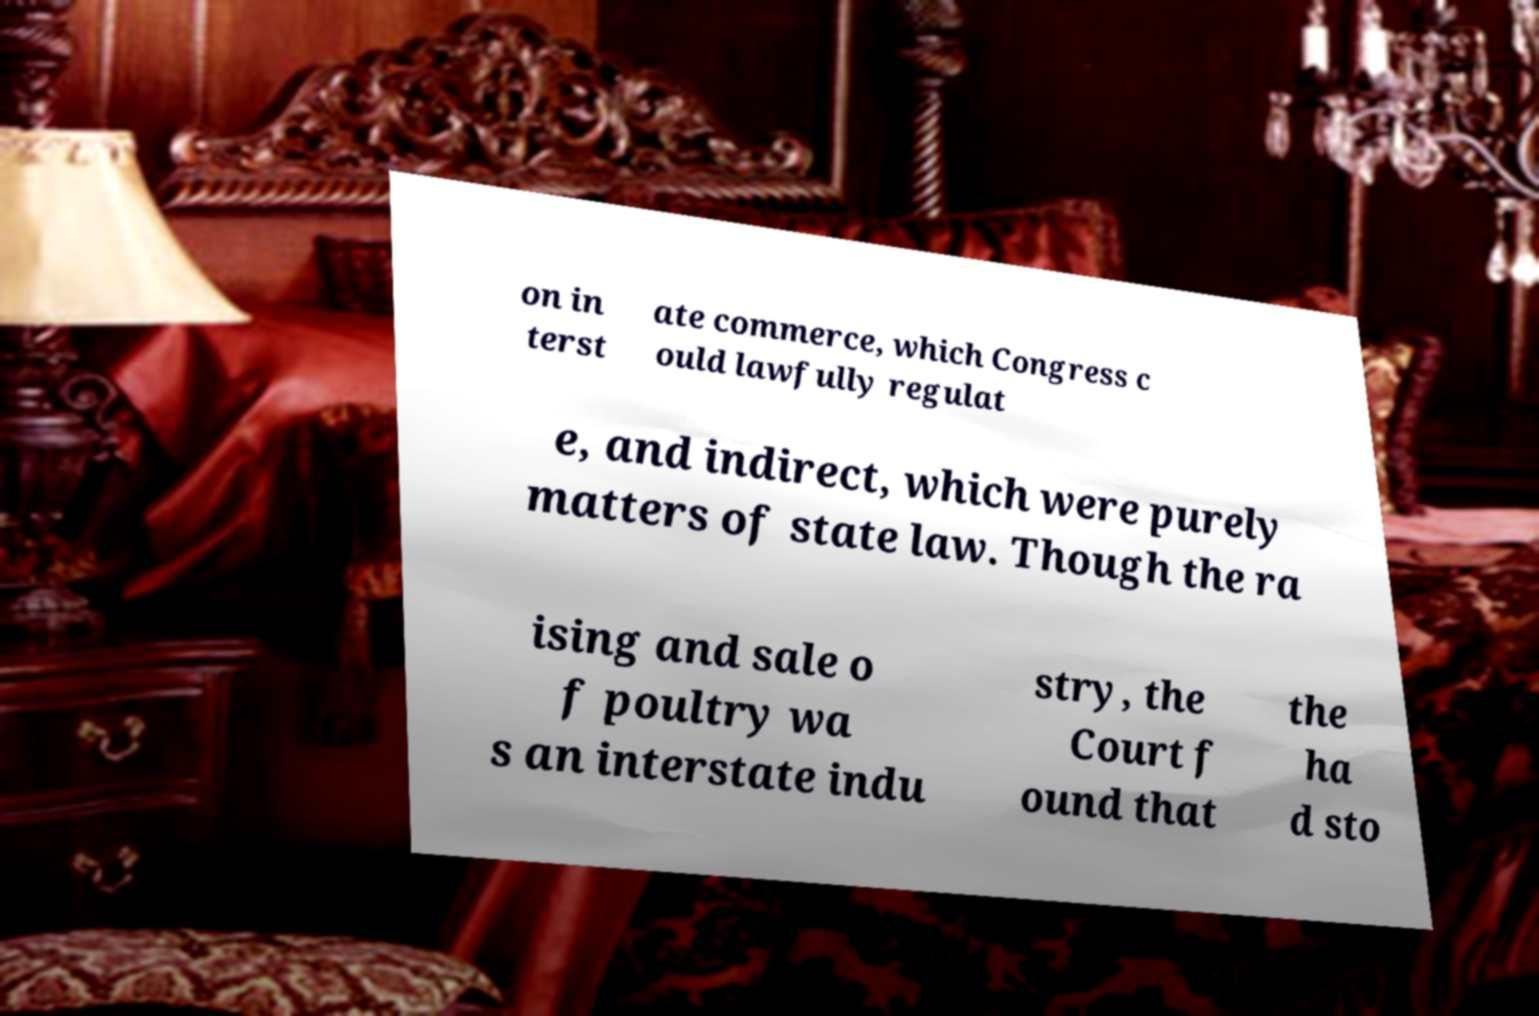Please read and relay the text visible in this image. What does it say? on in terst ate commerce, which Congress c ould lawfully regulat e, and indirect, which were purely matters of state law. Though the ra ising and sale o f poultry wa s an interstate indu stry, the Court f ound that the ha d sto 